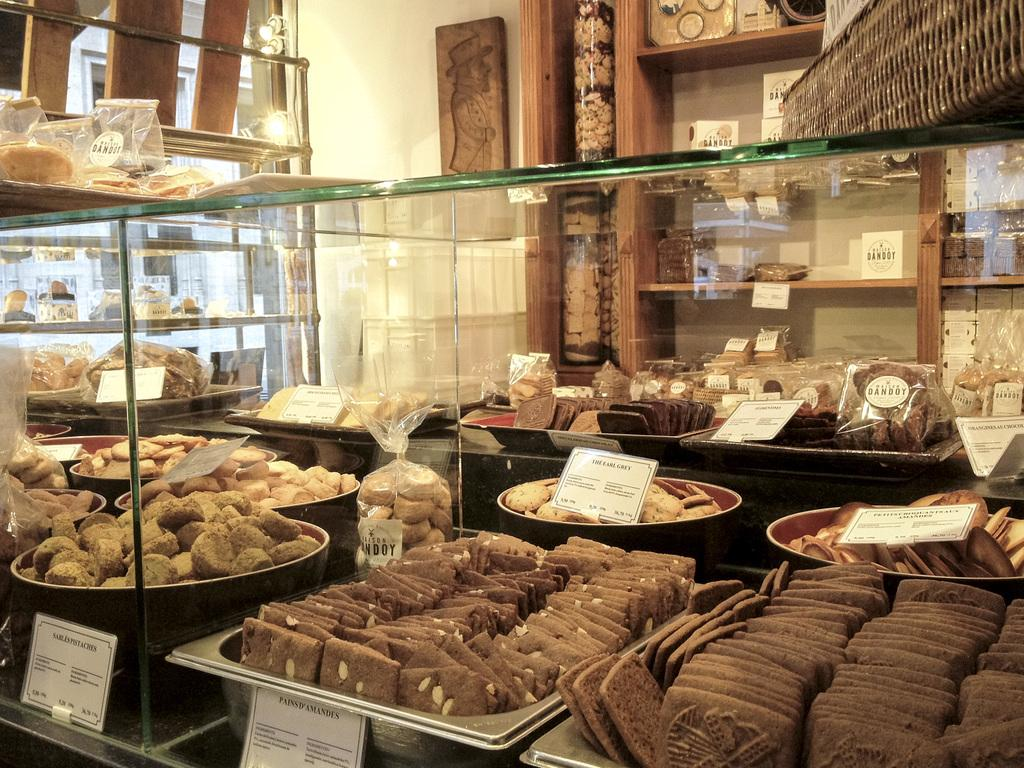What type of space is shown in the image? The image is an inside view of a room. What type of food can be seen in the room? There are cookies in the room. What type of storage items are present in the room? There are containers in the room. What type of furniture is present in the room? There are present. What type of surface is used for writing or displaying in the room? There are boards in the room. What type of beverage container is in the room? There is a glass in the room. What type of liquid storage items are in the room? There are bottles in the room. What type of storage furniture is in the room? There is a cupboard in the room. What type of decorative item is in the room? There is a photo frame in the room. What type of barrier is in the room? There is a wall in the room. What type of lighting is in the room? There are lights in the room. Is there a chessboard set up for a game in the image? There is no mention of a chessboard or a game in the image. Is there a stage for a performance in the room? There is no mention of a stage or a performance in the image. 